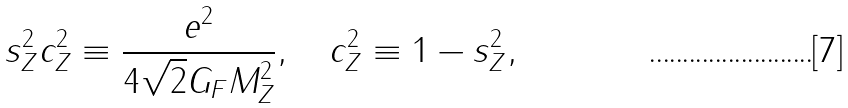Convert formula to latex. <formula><loc_0><loc_0><loc_500><loc_500>s _ { Z } ^ { 2 } c _ { Z } ^ { 2 } \equiv \frac { e ^ { 2 } } { 4 \sqrt { 2 } G _ { F } M _ { Z } ^ { 2 } } , \quad c _ { Z } ^ { 2 } \equiv 1 - s _ { Z } ^ { 2 } ,</formula> 